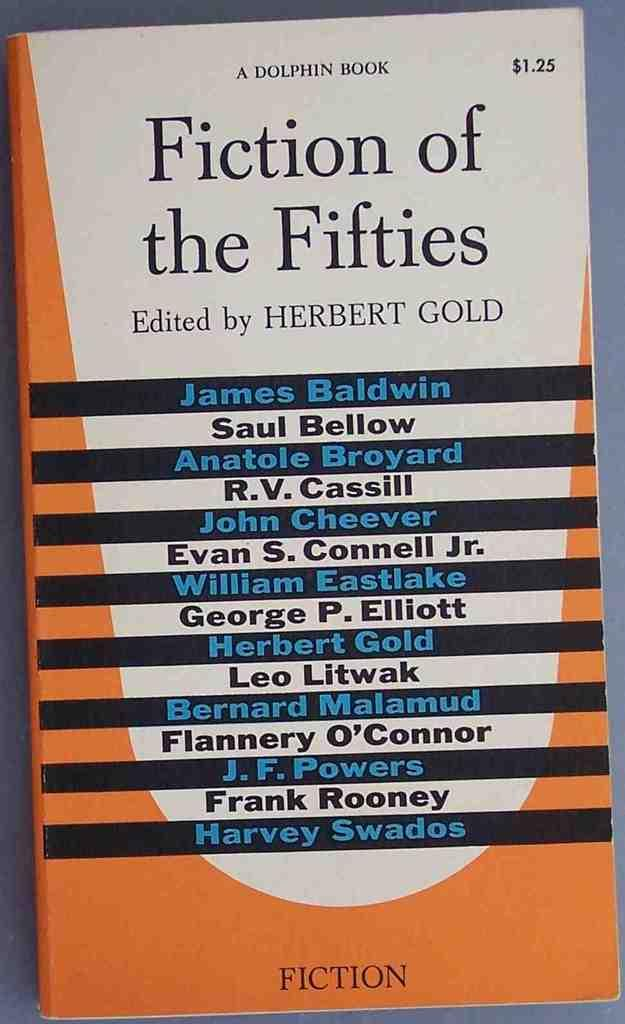<image>
Summarize the visual content of the image. A Fiction of the Fifties by Herbert Gold cost $1.25 